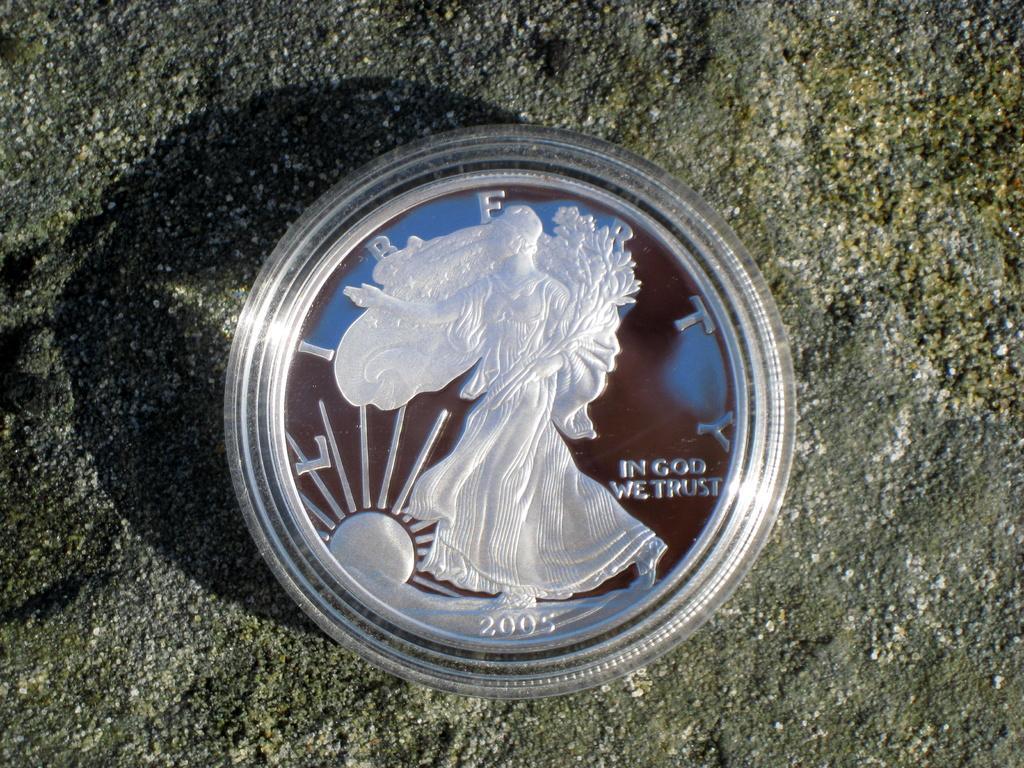In one or two sentences, can you explain what this image depicts? In this image we can see a coin on the wall, in the coin we can see the text and images. 